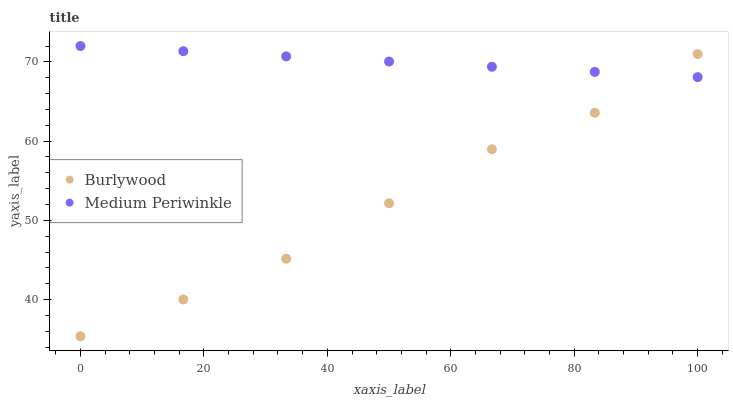Does Burlywood have the minimum area under the curve?
Answer yes or no. Yes. Does Medium Periwinkle have the maximum area under the curve?
Answer yes or no. Yes. Does Medium Periwinkle have the minimum area under the curve?
Answer yes or no. No. Is Medium Periwinkle the smoothest?
Answer yes or no. Yes. Is Burlywood the roughest?
Answer yes or no. Yes. Is Medium Periwinkle the roughest?
Answer yes or no. No. Does Burlywood have the lowest value?
Answer yes or no. Yes. Does Medium Periwinkle have the lowest value?
Answer yes or no. No. Does Medium Periwinkle have the highest value?
Answer yes or no. Yes. Does Burlywood intersect Medium Periwinkle?
Answer yes or no. Yes. Is Burlywood less than Medium Periwinkle?
Answer yes or no. No. Is Burlywood greater than Medium Periwinkle?
Answer yes or no. No. 